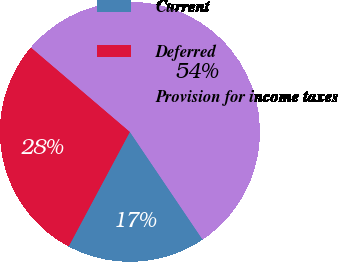Convert chart. <chart><loc_0><loc_0><loc_500><loc_500><pie_chart><fcel>Current<fcel>Deferred<fcel>Provision for income taxes<nl><fcel>17.26%<fcel>28.43%<fcel>54.31%<nl></chart> 